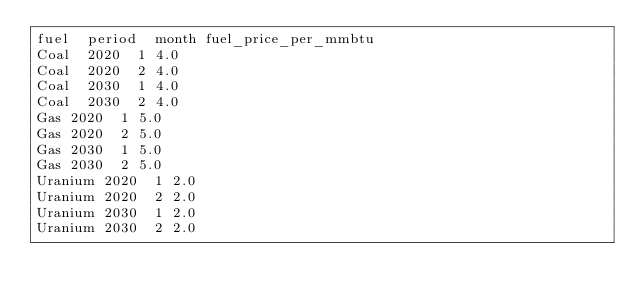<code> <loc_0><loc_0><loc_500><loc_500><_SQL_>fuel	period	month	fuel_price_per_mmbtu
Coal	2020	1	4.0
Coal	2020	2	4.0
Coal	2030	1	4.0
Coal	2030	2	4.0
Gas	2020	1	5.0
Gas	2020	2	5.0
Gas	2030	1	5.0
Gas	2030	2	5.0
Uranium	2020	1	2.0
Uranium	2020	2	2.0
Uranium	2030	1	2.0
Uranium	2030	2	2.0
</code> 